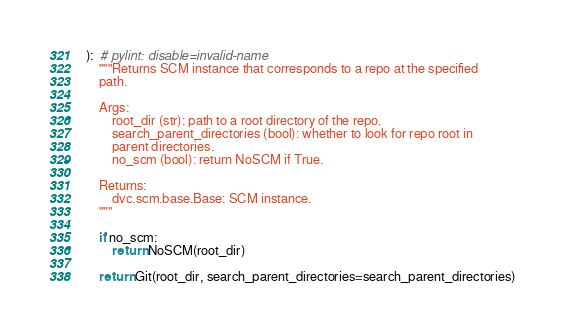Convert code to text. <code><loc_0><loc_0><loc_500><loc_500><_Python_>):  # pylint: disable=invalid-name
    """Returns SCM instance that corresponds to a repo at the specified
    path.

    Args:
        root_dir (str): path to a root directory of the repo.
        search_parent_directories (bool): whether to look for repo root in
        parent directories.
        no_scm (bool): return NoSCM if True.

    Returns:
        dvc.scm.base.Base: SCM instance.
    """

    if no_scm:
        return NoSCM(root_dir)

    return Git(root_dir, search_parent_directories=search_parent_directories)
</code> 